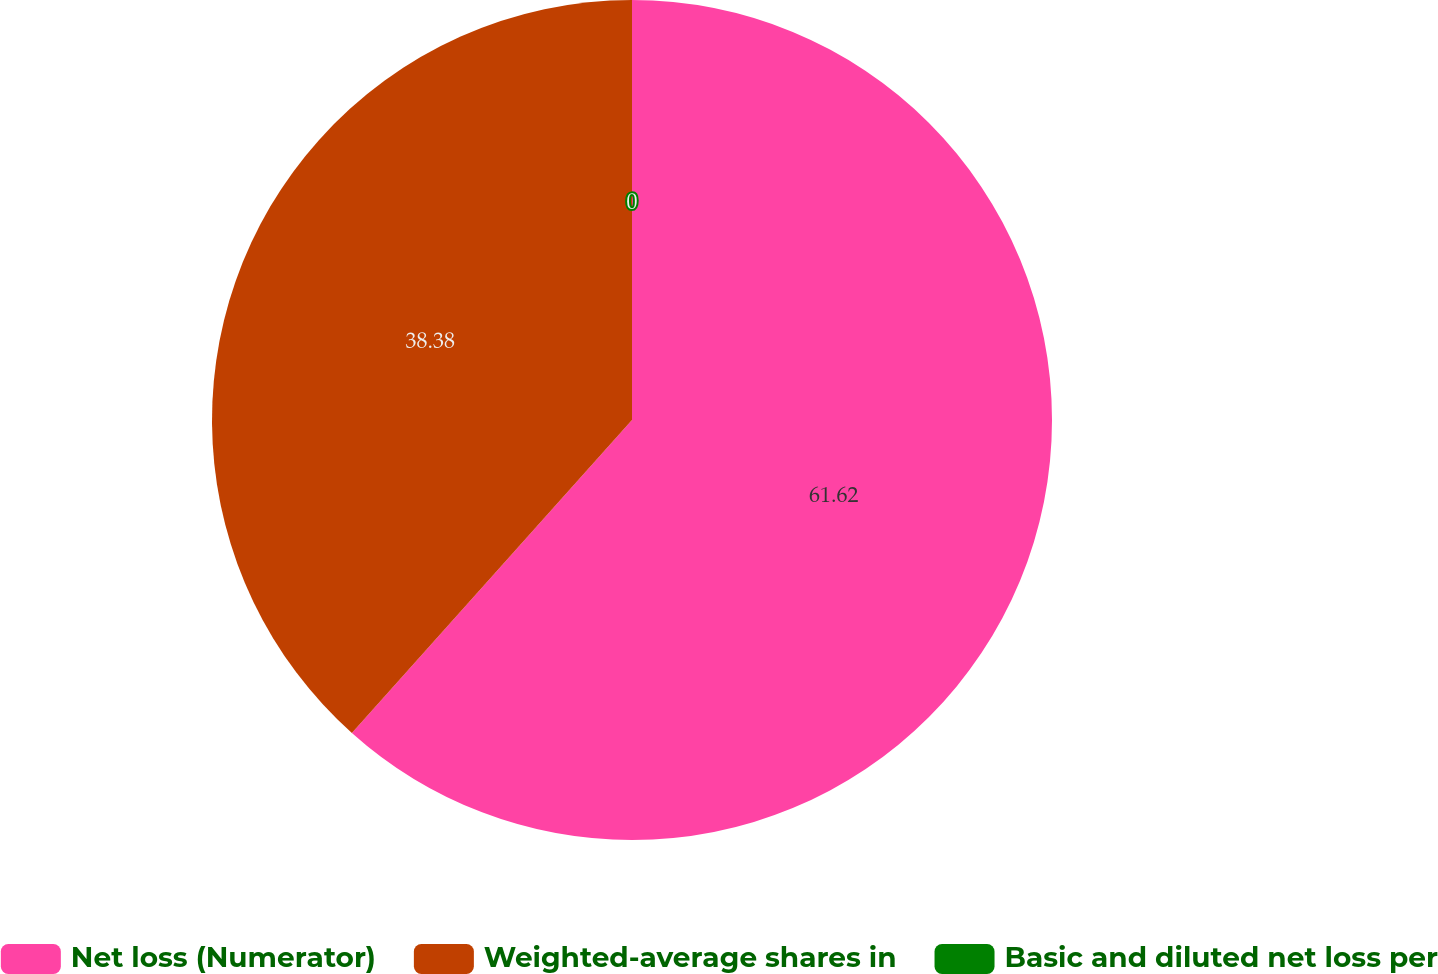Convert chart to OTSL. <chart><loc_0><loc_0><loc_500><loc_500><pie_chart><fcel>Net loss (Numerator)<fcel>Weighted-average shares in<fcel>Basic and diluted net loss per<nl><fcel>61.62%<fcel>38.38%<fcel>0.0%<nl></chart> 